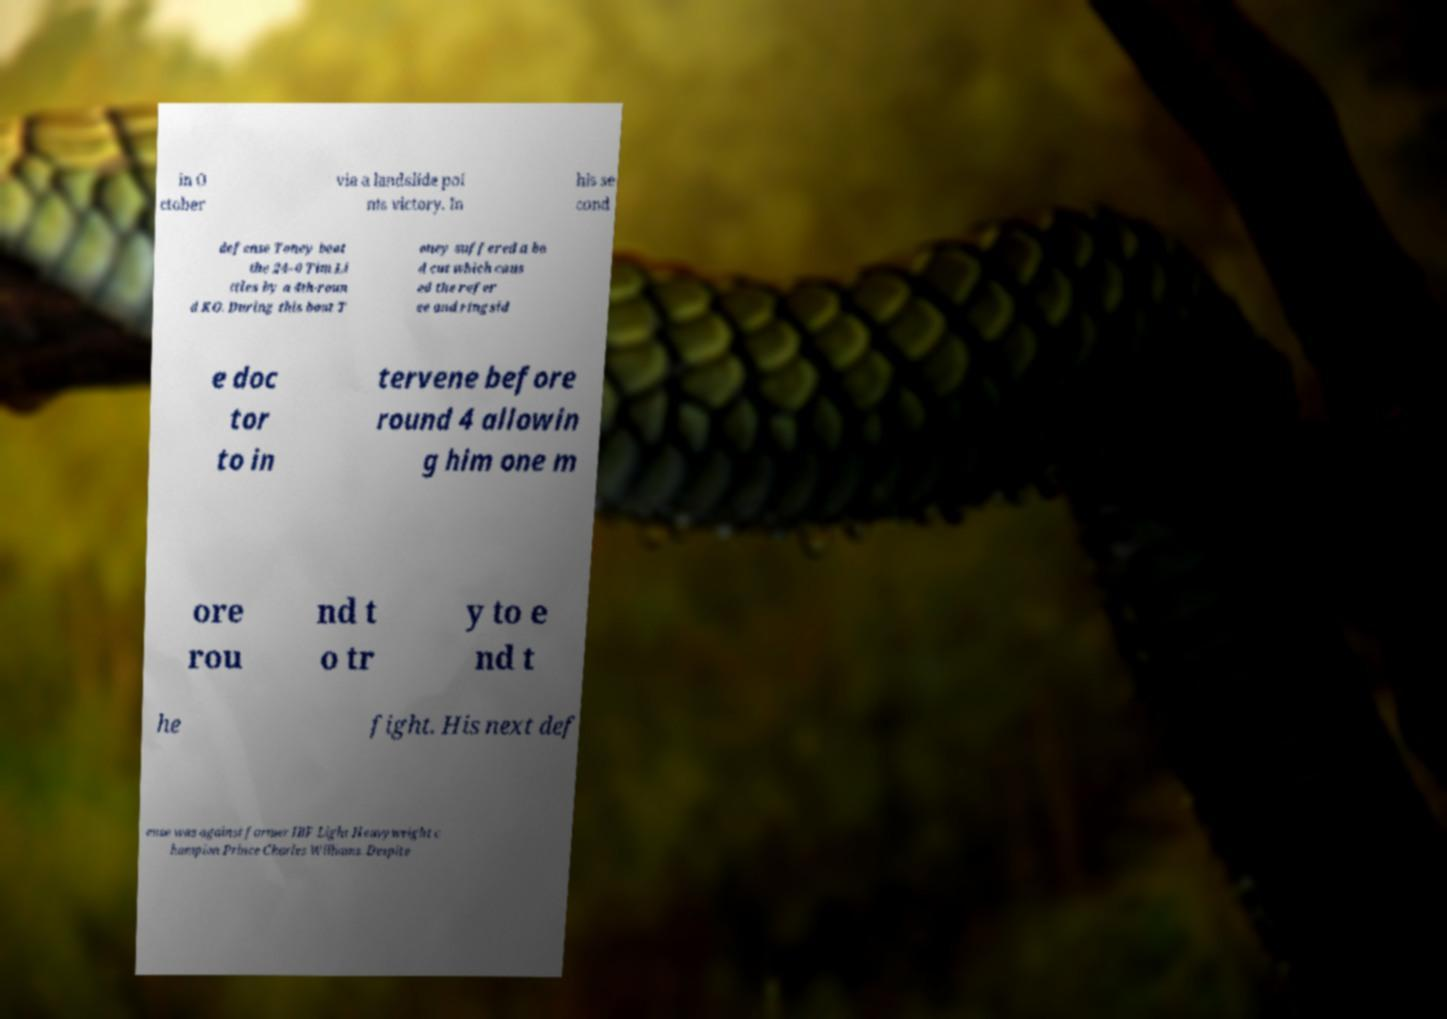Could you assist in decoding the text presented in this image and type it out clearly? in O ctober via a landslide poi nts victory. In his se cond defense Toney beat the 24–0 Tim Li ttles by a 4th-roun d KO. During this bout T oney suffered a ba d cut which caus ed the refer ee and ringsid e doc tor to in tervene before round 4 allowin g him one m ore rou nd t o tr y to e nd t he fight. His next def ense was against former IBF Light Heavyweight c hampion Prince Charles Williams. Despite 